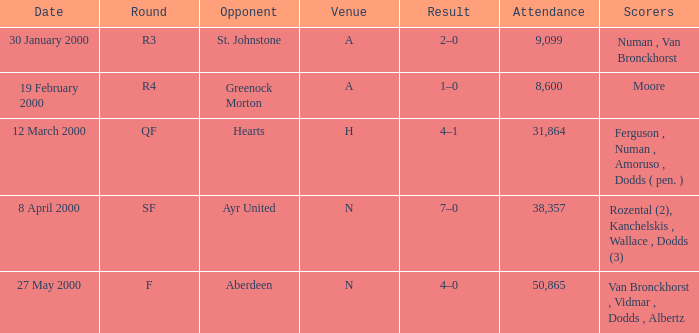Who were the individuals present on march 12, 2000? Ferguson , Numan , Amoruso , Dodds ( pen. ). 